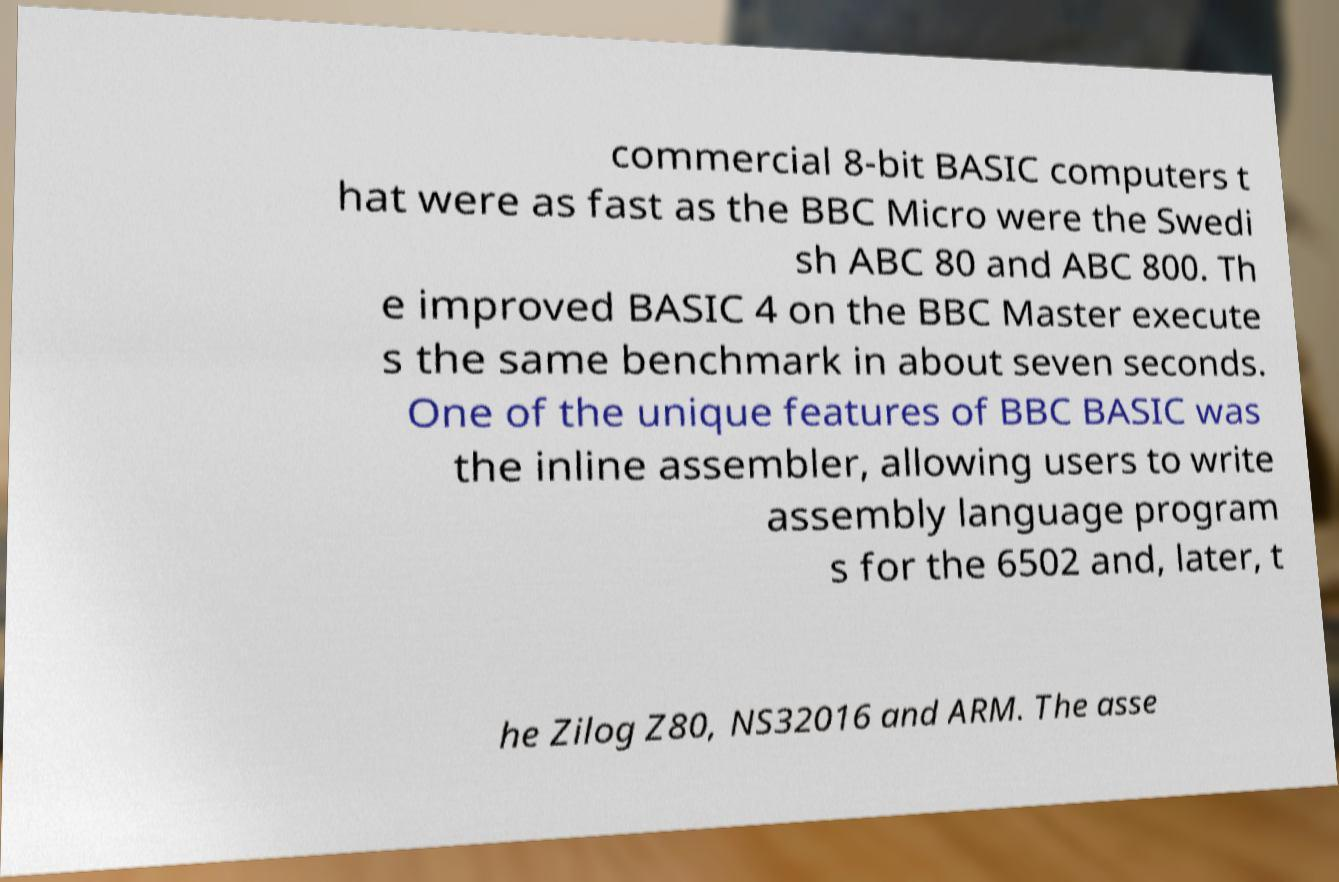Please read and relay the text visible in this image. What does it say? commercial 8-bit BASIC computers t hat were as fast as the BBC Micro were the Swedi sh ABC 80 and ABC 800. Th e improved BASIC 4 on the BBC Master execute s the same benchmark in about seven seconds. One of the unique features of BBC BASIC was the inline assembler, allowing users to write assembly language program s for the 6502 and, later, t he Zilog Z80, NS32016 and ARM. The asse 